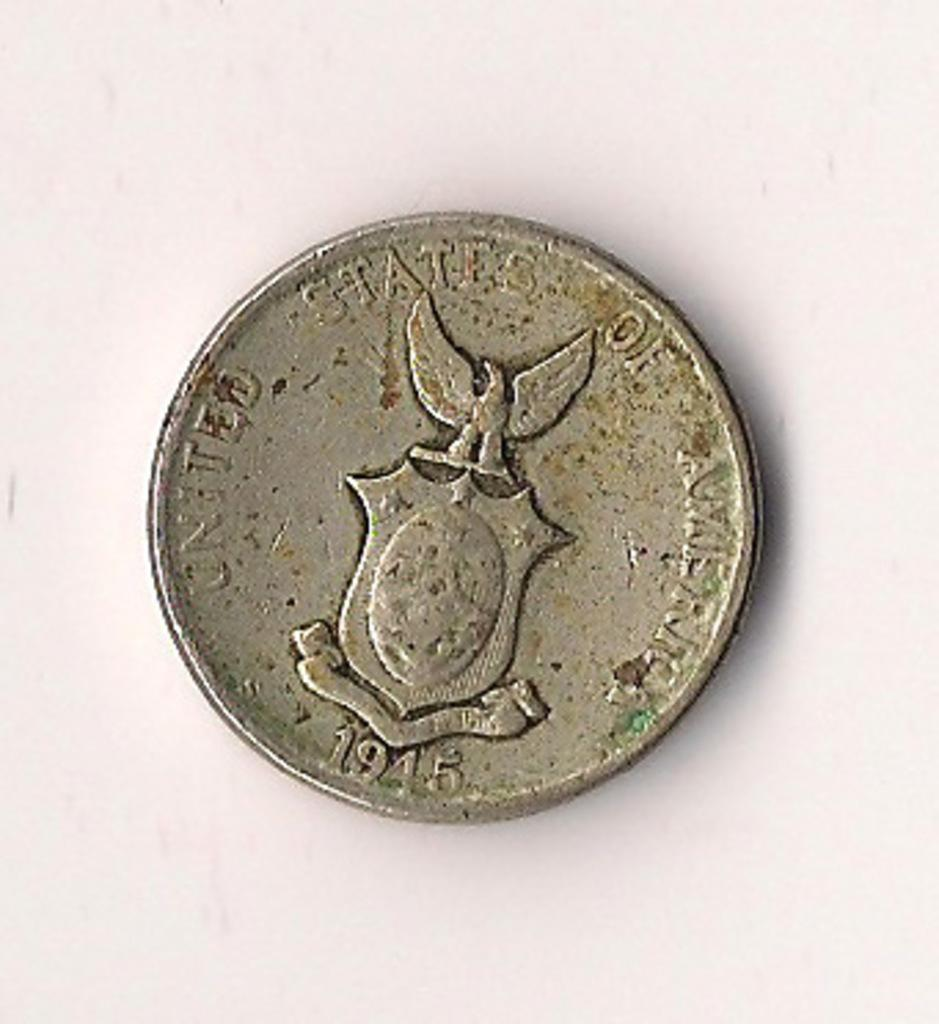<image>
Share a concise interpretation of the image provided. a coin that has the word United on it 